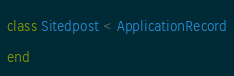<code> <loc_0><loc_0><loc_500><loc_500><_Ruby_>class Sitedpost < ApplicationRecord
end
</code> 